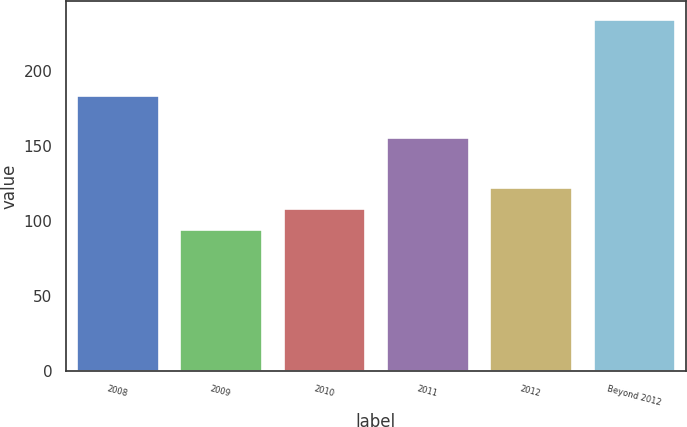<chart> <loc_0><loc_0><loc_500><loc_500><bar_chart><fcel>2008<fcel>2009<fcel>2010<fcel>2011<fcel>2012<fcel>Beyond 2012<nl><fcel>184<fcel>95<fcel>109<fcel>156<fcel>123<fcel>235<nl></chart> 